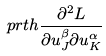<formula> <loc_0><loc_0><loc_500><loc_500>\ p r t h { \frac { \partial ^ { 2 } L } { \partial u ^ { \beta } _ { J } \partial u ^ { \alpha } _ { K } } }</formula> 